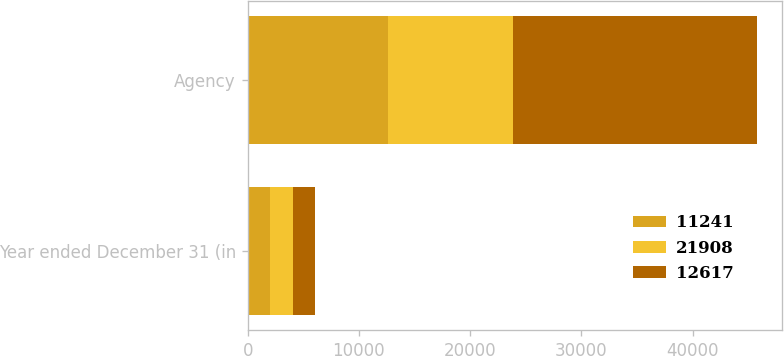<chart> <loc_0><loc_0><loc_500><loc_500><stacked_bar_chart><ecel><fcel>Year ended December 31 (in<fcel>Agency<nl><fcel>11241<fcel>2017<fcel>12617<nl><fcel>21908<fcel>2016<fcel>11241<nl><fcel>12617<fcel>2015<fcel>21908<nl></chart> 